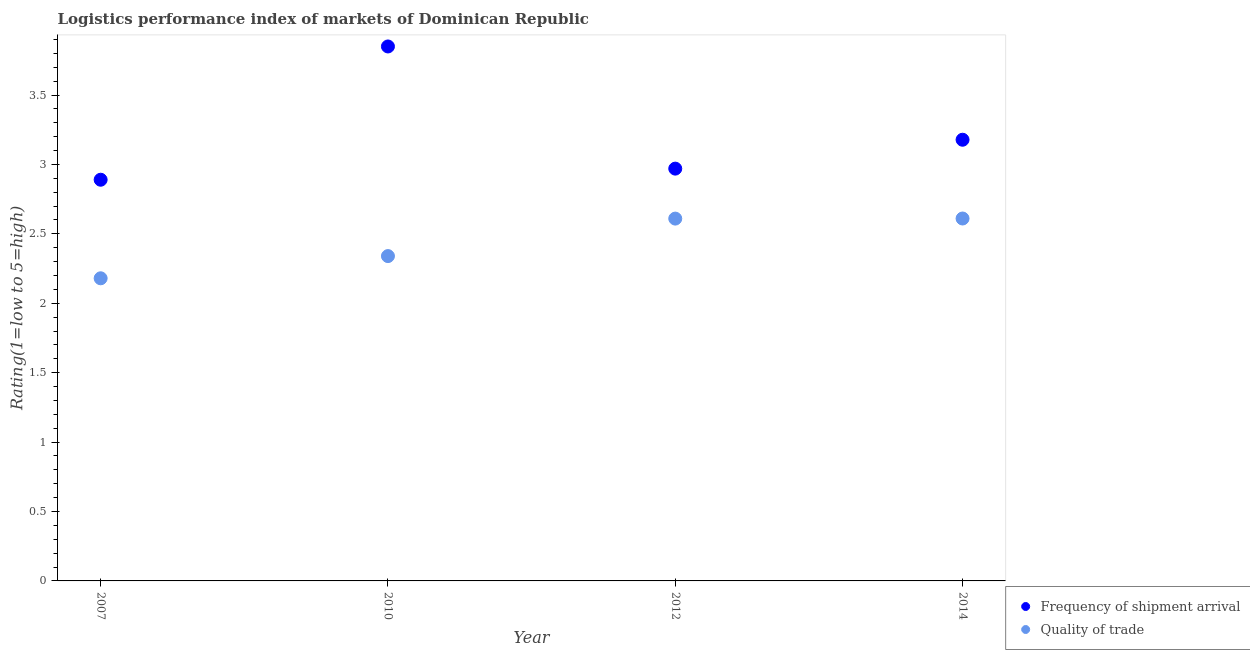What is the lpi of frequency of shipment arrival in 2007?
Provide a succinct answer. 2.89. Across all years, what is the maximum lpi quality of trade?
Ensure brevity in your answer.  2.61. Across all years, what is the minimum lpi quality of trade?
Your answer should be compact. 2.18. What is the total lpi quality of trade in the graph?
Your response must be concise. 9.74. What is the difference between the lpi quality of trade in 2007 and that in 2014?
Your response must be concise. -0.43. What is the difference between the lpi of frequency of shipment arrival in 2010 and the lpi quality of trade in 2012?
Your answer should be very brief. 1.24. What is the average lpi quality of trade per year?
Your answer should be compact. 2.44. In the year 2014, what is the difference between the lpi of frequency of shipment arrival and lpi quality of trade?
Your response must be concise. 0.57. What is the ratio of the lpi quality of trade in 2010 to that in 2012?
Offer a very short reply. 0.9. Is the lpi of frequency of shipment arrival in 2010 less than that in 2014?
Provide a short and direct response. No. What is the difference between the highest and the second highest lpi quality of trade?
Offer a very short reply. 0. What is the difference between the highest and the lowest lpi of frequency of shipment arrival?
Offer a terse response. 0.96. Is the lpi quality of trade strictly greater than the lpi of frequency of shipment arrival over the years?
Ensure brevity in your answer.  No. Is the lpi of frequency of shipment arrival strictly less than the lpi quality of trade over the years?
Make the answer very short. No. How many dotlines are there?
Keep it short and to the point. 2. Are the values on the major ticks of Y-axis written in scientific E-notation?
Your answer should be very brief. No. Does the graph contain grids?
Provide a short and direct response. No. What is the title of the graph?
Ensure brevity in your answer.  Logistics performance index of markets of Dominican Republic. What is the label or title of the Y-axis?
Provide a short and direct response. Rating(1=low to 5=high). What is the Rating(1=low to 5=high) in Frequency of shipment arrival in 2007?
Your answer should be compact. 2.89. What is the Rating(1=low to 5=high) in Quality of trade in 2007?
Offer a terse response. 2.18. What is the Rating(1=low to 5=high) in Frequency of shipment arrival in 2010?
Your answer should be very brief. 3.85. What is the Rating(1=low to 5=high) of Quality of trade in 2010?
Make the answer very short. 2.34. What is the Rating(1=low to 5=high) in Frequency of shipment arrival in 2012?
Provide a succinct answer. 2.97. What is the Rating(1=low to 5=high) of Quality of trade in 2012?
Give a very brief answer. 2.61. What is the Rating(1=low to 5=high) in Frequency of shipment arrival in 2014?
Your answer should be compact. 3.18. What is the Rating(1=low to 5=high) of Quality of trade in 2014?
Your response must be concise. 2.61. Across all years, what is the maximum Rating(1=low to 5=high) of Frequency of shipment arrival?
Keep it short and to the point. 3.85. Across all years, what is the maximum Rating(1=low to 5=high) of Quality of trade?
Give a very brief answer. 2.61. Across all years, what is the minimum Rating(1=low to 5=high) in Frequency of shipment arrival?
Provide a succinct answer. 2.89. Across all years, what is the minimum Rating(1=low to 5=high) in Quality of trade?
Give a very brief answer. 2.18. What is the total Rating(1=low to 5=high) in Frequency of shipment arrival in the graph?
Keep it short and to the point. 12.89. What is the total Rating(1=low to 5=high) in Quality of trade in the graph?
Keep it short and to the point. 9.74. What is the difference between the Rating(1=low to 5=high) of Frequency of shipment arrival in 2007 and that in 2010?
Give a very brief answer. -0.96. What is the difference between the Rating(1=low to 5=high) in Quality of trade in 2007 and that in 2010?
Ensure brevity in your answer.  -0.16. What is the difference between the Rating(1=low to 5=high) of Frequency of shipment arrival in 2007 and that in 2012?
Ensure brevity in your answer.  -0.08. What is the difference between the Rating(1=low to 5=high) in Quality of trade in 2007 and that in 2012?
Your answer should be very brief. -0.43. What is the difference between the Rating(1=low to 5=high) of Frequency of shipment arrival in 2007 and that in 2014?
Your answer should be compact. -0.29. What is the difference between the Rating(1=low to 5=high) of Quality of trade in 2007 and that in 2014?
Give a very brief answer. -0.43. What is the difference between the Rating(1=low to 5=high) of Frequency of shipment arrival in 2010 and that in 2012?
Make the answer very short. 0.88. What is the difference between the Rating(1=low to 5=high) in Quality of trade in 2010 and that in 2012?
Provide a succinct answer. -0.27. What is the difference between the Rating(1=low to 5=high) in Frequency of shipment arrival in 2010 and that in 2014?
Make the answer very short. 0.67. What is the difference between the Rating(1=low to 5=high) of Quality of trade in 2010 and that in 2014?
Ensure brevity in your answer.  -0.27. What is the difference between the Rating(1=low to 5=high) of Frequency of shipment arrival in 2012 and that in 2014?
Your response must be concise. -0.21. What is the difference between the Rating(1=low to 5=high) of Quality of trade in 2012 and that in 2014?
Offer a very short reply. -0. What is the difference between the Rating(1=low to 5=high) in Frequency of shipment arrival in 2007 and the Rating(1=low to 5=high) in Quality of trade in 2010?
Offer a terse response. 0.55. What is the difference between the Rating(1=low to 5=high) in Frequency of shipment arrival in 2007 and the Rating(1=low to 5=high) in Quality of trade in 2012?
Your answer should be compact. 0.28. What is the difference between the Rating(1=low to 5=high) of Frequency of shipment arrival in 2007 and the Rating(1=low to 5=high) of Quality of trade in 2014?
Your response must be concise. 0.28. What is the difference between the Rating(1=low to 5=high) in Frequency of shipment arrival in 2010 and the Rating(1=low to 5=high) in Quality of trade in 2012?
Give a very brief answer. 1.24. What is the difference between the Rating(1=low to 5=high) of Frequency of shipment arrival in 2010 and the Rating(1=low to 5=high) of Quality of trade in 2014?
Offer a terse response. 1.24. What is the difference between the Rating(1=low to 5=high) in Frequency of shipment arrival in 2012 and the Rating(1=low to 5=high) in Quality of trade in 2014?
Your answer should be compact. 0.36. What is the average Rating(1=low to 5=high) of Frequency of shipment arrival per year?
Your answer should be compact. 3.22. What is the average Rating(1=low to 5=high) in Quality of trade per year?
Your answer should be compact. 2.44. In the year 2007, what is the difference between the Rating(1=low to 5=high) of Frequency of shipment arrival and Rating(1=low to 5=high) of Quality of trade?
Ensure brevity in your answer.  0.71. In the year 2010, what is the difference between the Rating(1=low to 5=high) in Frequency of shipment arrival and Rating(1=low to 5=high) in Quality of trade?
Make the answer very short. 1.51. In the year 2012, what is the difference between the Rating(1=low to 5=high) of Frequency of shipment arrival and Rating(1=low to 5=high) of Quality of trade?
Your answer should be very brief. 0.36. In the year 2014, what is the difference between the Rating(1=low to 5=high) of Frequency of shipment arrival and Rating(1=low to 5=high) of Quality of trade?
Your answer should be compact. 0.57. What is the ratio of the Rating(1=low to 5=high) in Frequency of shipment arrival in 2007 to that in 2010?
Your answer should be compact. 0.75. What is the ratio of the Rating(1=low to 5=high) of Quality of trade in 2007 to that in 2010?
Your answer should be compact. 0.93. What is the ratio of the Rating(1=low to 5=high) of Frequency of shipment arrival in 2007 to that in 2012?
Keep it short and to the point. 0.97. What is the ratio of the Rating(1=low to 5=high) in Quality of trade in 2007 to that in 2012?
Provide a succinct answer. 0.84. What is the ratio of the Rating(1=low to 5=high) in Frequency of shipment arrival in 2007 to that in 2014?
Provide a short and direct response. 0.91. What is the ratio of the Rating(1=low to 5=high) of Quality of trade in 2007 to that in 2014?
Offer a terse response. 0.83. What is the ratio of the Rating(1=low to 5=high) of Frequency of shipment arrival in 2010 to that in 2012?
Offer a very short reply. 1.3. What is the ratio of the Rating(1=low to 5=high) of Quality of trade in 2010 to that in 2012?
Offer a very short reply. 0.9. What is the ratio of the Rating(1=low to 5=high) in Frequency of shipment arrival in 2010 to that in 2014?
Give a very brief answer. 1.21. What is the ratio of the Rating(1=low to 5=high) of Quality of trade in 2010 to that in 2014?
Offer a very short reply. 0.9. What is the ratio of the Rating(1=low to 5=high) in Frequency of shipment arrival in 2012 to that in 2014?
Give a very brief answer. 0.93. What is the ratio of the Rating(1=low to 5=high) in Quality of trade in 2012 to that in 2014?
Offer a terse response. 1. What is the difference between the highest and the second highest Rating(1=low to 5=high) in Frequency of shipment arrival?
Keep it short and to the point. 0.67. What is the difference between the highest and the second highest Rating(1=low to 5=high) of Quality of trade?
Make the answer very short. 0. What is the difference between the highest and the lowest Rating(1=low to 5=high) in Quality of trade?
Give a very brief answer. 0.43. 